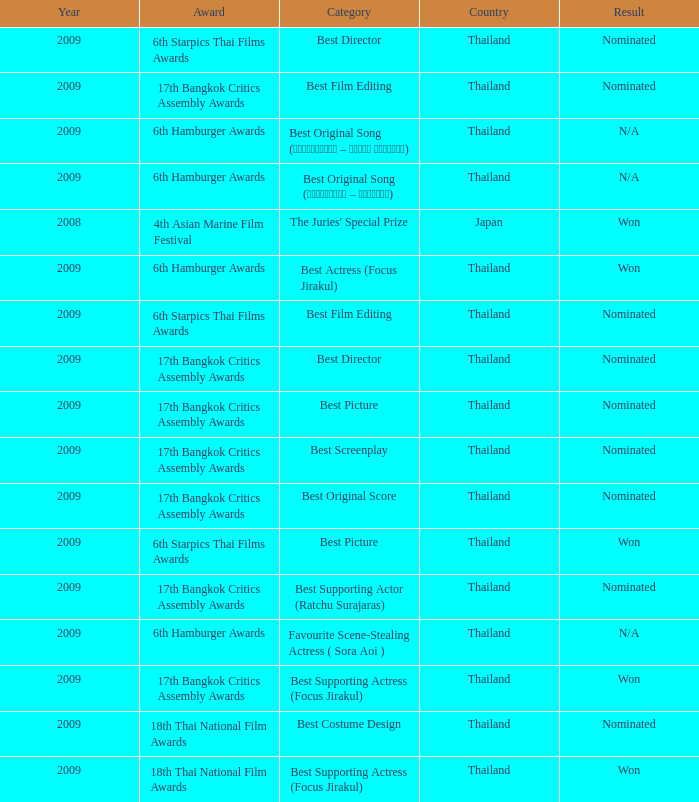Give me the full table as a dictionary. {'header': ['Year', 'Award', 'Category', 'Country', 'Result'], 'rows': [['2009', '6th Starpics Thai Films Awards', 'Best Director', 'Thailand', 'Nominated'], ['2009', '17th Bangkok Critics Assembly Awards', 'Best Film Editing', 'Thailand', 'Nominated'], ['2009', '6th Hamburger Awards', 'Best Original Song (รอเธอหันมา – โฟกัส จิระกุล)', 'Thailand', 'N/A'], ['2009', '6th Hamburger Awards', 'Best Original Song (อย่างน้อย – บิ๊กแอส)', 'Thailand', 'N/A'], ['2008', '4th Asian Marine Film Festival', "The Juries' Special Prize", 'Japan', 'Won'], ['2009', '6th Hamburger Awards', 'Best Actress (Focus Jirakul)', 'Thailand', 'Won'], ['2009', '6th Starpics Thai Films Awards', 'Best Film Editing', 'Thailand', 'Nominated'], ['2009', '17th Bangkok Critics Assembly Awards', 'Best Director', 'Thailand', 'Nominated'], ['2009', '17th Bangkok Critics Assembly Awards', 'Best Picture', 'Thailand', 'Nominated'], ['2009', '17th Bangkok Critics Assembly Awards', 'Best Screenplay', 'Thailand', 'Nominated'], ['2009', '17th Bangkok Critics Assembly Awards', 'Best Original Score', 'Thailand', 'Nominated'], ['2009', '6th Starpics Thai Films Awards', 'Best Picture', 'Thailand', 'Won'], ['2009', '17th Bangkok Critics Assembly Awards', 'Best Supporting Actor (Ratchu Surajaras)', 'Thailand', 'Nominated'], ['2009', '6th Hamburger Awards', 'Favourite Scene-Stealing Actress ( Sora Aoi )', 'Thailand', 'N/A'], ['2009', '17th Bangkok Critics Assembly Awards', 'Best Supporting Actress (Focus Jirakul)', 'Thailand', 'Won'], ['2009', '18th Thai National Film Awards', 'Best Costume Design', 'Thailand', 'Nominated'], ['2009', '18th Thai National Film Awards', 'Best Supporting Actress (Focus Jirakul)', 'Thailand', 'Won']]} Which Country has a Result of nominated, an Award of 17th bangkok critics assembly awards, and a Category of best screenplay? Thailand. 